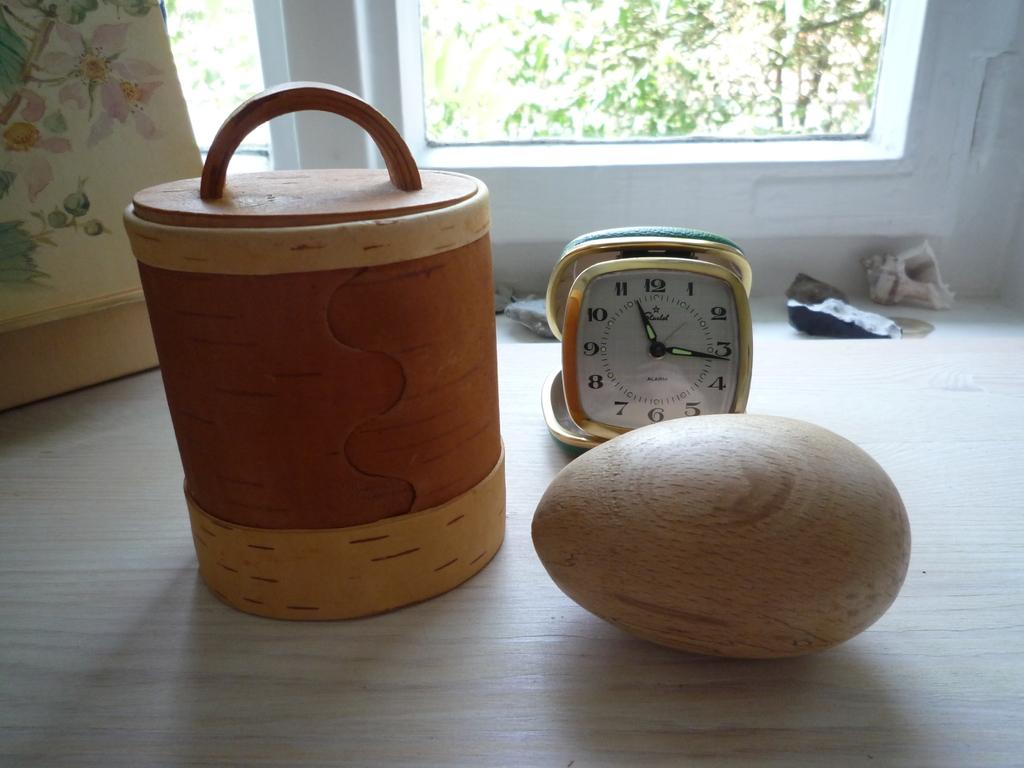What time does it read on the clock?
Your response must be concise. 11:16. 